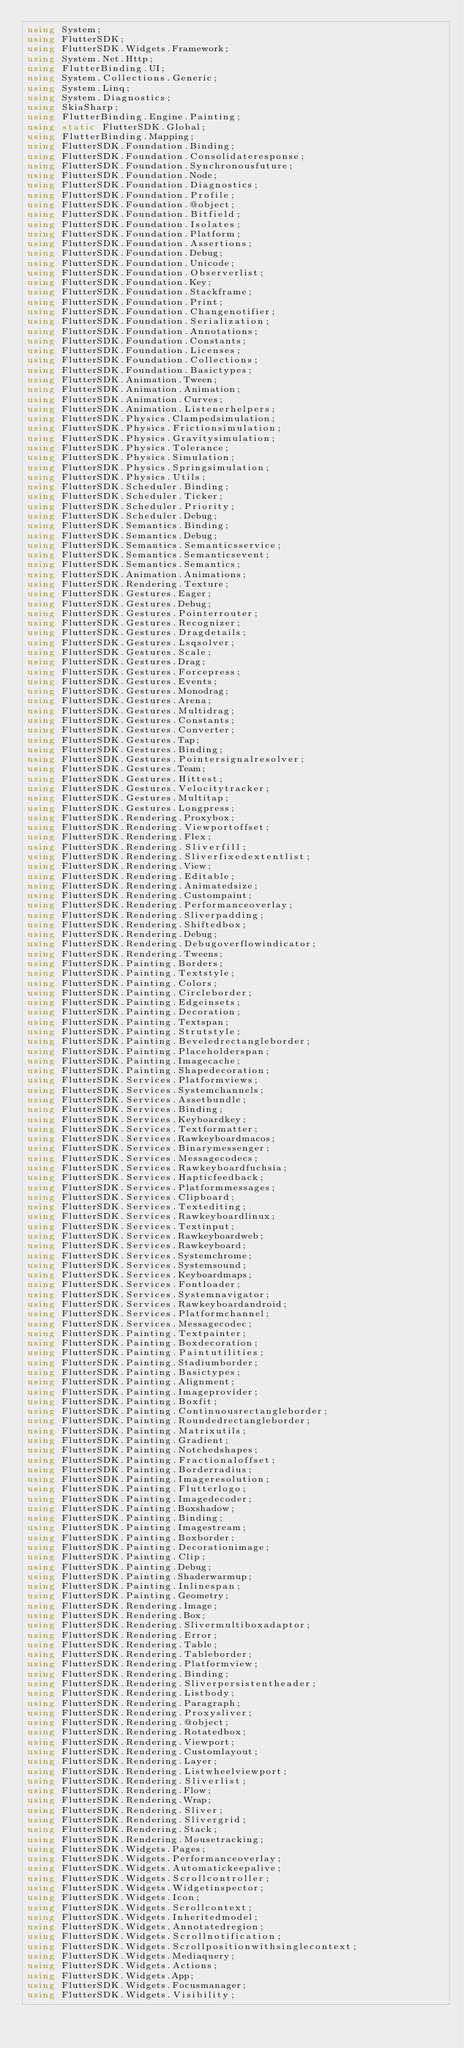<code> <loc_0><loc_0><loc_500><loc_500><_C#_>using System;
using FlutterSDK;
using FlutterSDK.Widgets.Framework;
using System.Net.Http;
using FlutterBinding.UI;
using System.Collections.Generic;
using System.Linq;
using System.Diagnostics;
using SkiaSharp;
using FlutterBinding.Engine.Painting;
using static FlutterSDK.Global;
using FlutterBinding.Mapping;
using FlutterSDK.Foundation.Binding;
using FlutterSDK.Foundation.Consolidateresponse;
using FlutterSDK.Foundation.Synchronousfuture;
using FlutterSDK.Foundation.Node;
using FlutterSDK.Foundation.Diagnostics;
using FlutterSDK.Foundation.Profile;
using FlutterSDK.Foundation.@object;
using FlutterSDK.Foundation.Bitfield;
using FlutterSDK.Foundation.Isolates;
using FlutterSDK.Foundation.Platform;
using FlutterSDK.Foundation.Assertions;
using FlutterSDK.Foundation.Debug;
using FlutterSDK.Foundation.Unicode;
using FlutterSDK.Foundation.Observerlist;
using FlutterSDK.Foundation.Key;
using FlutterSDK.Foundation.Stackframe;
using FlutterSDK.Foundation.Print;
using FlutterSDK.Foundation.Changenotifier;
using FlutterSDK.Foundation.Serialization;
using FlutterSDK.Foundation.Annotations;
using FlutterSDK.Foundation.Constants;
using FlutterSDK.Foundation.Licenses;
using FlutterSDK.Foundation.Collections;
using FlutterSDK.Foundation.Basictypes;
using FlutterSDK.Animation.Tween;
using FlutterSDK.Animation.Animation;
using FlutterSDK.Animation.Curves;
using FlutterSDK.Animation.Listenerhelpers;
using FlutterSDK.Physics.Clampedsimulation;
using FlutterSDK.Physics.Frictionsimulation;
using FlutterSDK.Physics.Gravitysimulation;
using FlutterSDK.Physics.Tolerance;
using FlutterSDK.Physics.Simulation;
using FlutterSDK.Physics.Springsimulation;
using FlutterSDK.Physics.Utils;
using FlutterSDK.Scheduler.Binding;
using FlutterSDK.Scheduler.Ticker;
using FlutterSDK.Scheduler.Priority;
using FlutterSDK.Scheduler.Debug;
using FlutterSDK.Semantics.Binding;
using FlutterSDK.Semantics.Debug;
using FlutterSDK.Semantics.Semanticsservice;
using FlutterSDK.Semantics.Semanticsevent;
using FlutterSDK.Semantics.Semantics;
using FlutterSDK.Animation.Animations;
using FlutterSDK.Rendering.Texture;
using FlutterSDK.Gestures.Eager;
using FlutterSDK.Gestures.Debug;
using FlutterSDK.Gestures.Pointerrouter;
using FlutterSDK.Gestures.Recognizer;
using FlutterSDK.Gestures.Dragdetails;
using FlutterSDK.Gestures.Lsqsolver;
using FlutterSDK.Gestures.Scale;
using FlutterSDK.Gestures.Drag;
using FlutterSDK.Gestures.Forcepress;
using FlutterSDK.Gestures.Events;
using FlutterSDK.Gestures.Monodrag;
using FlutterSDK.Gestures.Arena;
using FlutterSDK.Gestures.Multidrag;
using FlutterSDK.Gestures.Constants;
using FlutterSDK.Gestures.Converter;
using FlutterSDK.Gestures.Tap;
using FlutterSDK.Gestures.Binding;
using FlutterSDK.Gestures.Pointersignalresolver;
using FlutterSDK.Gestures.Team;
using FlutterSDK.Gestures.Hittest;
using FlutterSDK.Gestures.Velocitytracker;
using FlutterSDK.Gestures.Multitap;
using FlutterSDK.Gestures.Longpress;
using FlutterSDK.Rendering.Proxybox;
using FlutterSDK.Rendering.Viewportoffset;
using FlutterSDK.Rendering.Flex;
using FlutterSDK.Rendering.Sliverfill;
using FlutterSDK.Rendering.Sliverfixedextentlist;
using FlutterSDK.Rendering.View;
using FlutterSDK.Rendering.Editable;
using FlutterSDK.Rendering.Animatedsize;
using FlutterSDK.Rendering.Custompaint;
using FlutterSDK.Rendering.Performanceoverlay;
using FlutterSDK.Rendering.Sliverpadding;
using FlutterSDK.Rendering.Shiftedbox;
using FlutterSDK.Rendering.Debug;
using FlutterSDK.Rendering.Debugoverflowindicator;
using FlutterSDK.Rendering.Tweens;
using FlutterSDK.Painting.Borders;
using FlutterSDK.Painting.Textstyle;
using FlutterSDK.Painting.Colors;
using FlutterSDK.Painting.Circleborder;
using FlutterSDK.Painting.Edgeinsets;
using FlutterSDK.Painting.Decoration;
using FlutterSDK.Painting.Textspan;
using FlutterSDK.Painting.Strutstyle;
using FlutterSDK.Painting.Beveledrectangleborder;
using FlutterSDK.Painting.Placeholderspan;
using FlutterSDK.Painting.Imagecache;
using FlutterSDK.Painting.Shapedecoration;
using FlutterSDK.Services.Platformviews;
using FlutterSDK.Services.Systemchannels;
using FlutterSDK.Services.Assetbundle;
using FlutterSDK.Services.Binding;
using FlutterSDK.Services.Keyboardkey;
using FlutterSDK.Services.Textformatter;
using FlutterSDK.Services.Rawkeyboardmacos;
using FlutterSDK.Services.Binarymessenger;
using FlutterSDK.Services.Messagecodecs;
using FlutterSDK.Services.Rawkeyboardfuchsia;
using FlutterSDK.Services.Hapticfeedback;
using FlutterSDK.Services.Platformmessages;
using FlutterSDK.Services.Clipboard;
using FlutterSDK.Services.Textediting;
using FlutterSDK.Services.Rawkeyboardlinux;
using FlutterSDK.Services.Textinput;
using FlutterSDK.Services.Rawkeyboardweb;
using FlutterSDK.Services.Rawkeyboard;
using FlutterSDK.Services.Systemchrome;
using FlutterSDK.Services.Systemsound;
using FlutterSDK.Services.Keyboardmaps;
using FlutterSDK.Services.Fontloader;
using FlutterSDK.Services.Systemnavigator;
using FlutterSDK.Services.Rawkeyboardandroid;
using FlutterSDK.Services.Platformchannel;
using FlutterSDK.Services.Messagecodec;
using FlutterSDK.Painting.Textpainter;
using FlutterSDK.Painting.Boxdecoration;
using FlutterSDK.Painting.Paintutilities;
using FlutterSDK.Painting.Stadiumborder;
using FlutterSDK.Painting.Basictypes;
using FlutterSDK.Painting.Alignment;
using FlutterSDK.Painting.Imageprovider;
using FlutterSDK.Painting.Boxfit;
using FlutterSDK.Painting.Continuousrectangleborder;
using FlutterSDK.Painting.Roundedrectangleborder;
using FlutterSDK.Painting.Matrixutils;
using FlutterSDK.Painting.Gradient;
using FlutterSDK.Painting.Notchedshapes;
using FlutterSDK.Painting.Fractionaloffset;
using FlutterSDK.Painting.Borderradius;
using FlutterSDK.Painting.Imageresolution;
using FlutterSDK.Painting.Flutterlogo;
using FlutterSDK.Painting.Imagedecoder;
using FlutterSDK.Painting.Boxshadow;
using FlutterSDK.Painting.Binding;
using FlutterSDK.Painting.Imagestream;
using FlutterSDK.Painting.Boxborder;
using FlutterSDK.Painting.Decorationimage;
using FlutterSDK.Painting.Clip;
using FlutterSDK.Painting.Debug;
using FlutterSDK.Painting.Shaderwarmup;
using FlutterSDK.Painting.Inlinespan;
using FlutterSDK.Painting.Geometry;
using FlutterSDK.Rendering.Image;
using FlutterSDK.Rendering.Box;
using FlutterSDK.Rendering.Slivermultiboxadaptor;
using FlutterSDK.Rendering.Error;
using FlutterSDK.Rendering.Table;
using FlutterSDK.Rendering.Tableborder;
using FlutterSDK.Rendering.Platformview;
using FlutterSDK.Rendering.Binding;
using FlutterSDK.Rendering.Sliverpersistentheader;
using FlutterSDK.Rendering.Listbody;
using FlutterSDK.Rendering.Paragraph;
using FlutterSDK.Rendering.Proxysliver;
using FlutterSDK.Rendering.@object;
using FlutterSDK.Rendering.Rotatedbox;
using FlutterSDK.Rendering.Viewport;
using FlutterSDK.Rendering.Customlayout;
using FlutterSDK.Rendering.Layer;
using FlutterSDK.Rendering.Listwheelviewport;
using FlutterSDK.Rendering.Sliverlist;
using FlutterSDK.Rendering.Flow;
using FlutterSDK.Rendering.Wrap;
using FlutterSDK.Rendering.Sliver;
using FlutterSDK.Rendering.Slivergrid;
using FlutterSDK.Rendering.Stack;
using FlutterSDK.Rendering.Mousetracking;
using FlutterSDK.Widgets.Pages;
using FlutterSDK.Widgets.Performanceoverlay;
using FlutterSDK.Widgets.Automatickeepalive;
using FlutterSDK.Widgets.Scrollcontroller;
using FlutterSDK.Widgets.Widgetinspector;
using FlutterSDK.Widgets.Icon;
using FlutterSDK.Widgets.Scrollcontext;
using FlutterSDK.Widgets.Inheritedmodel;
using FlutterSDK.Widgets.Annotatedregion;
using FlutterSDK.Widgets.Scrollnotification;
using FlutterSDK.Widgets.Scrollpositionwithsinglecontext;
using FlutterSDK.Widgets.Mediaquery;
using FlutterSDK.Widgets.Actions;
using FlutterSDK.Widgets.App;
using FlutterSDK.Widgets.Focusmanager;
using FlutterSDK.Widgets.Visibility;</code> 